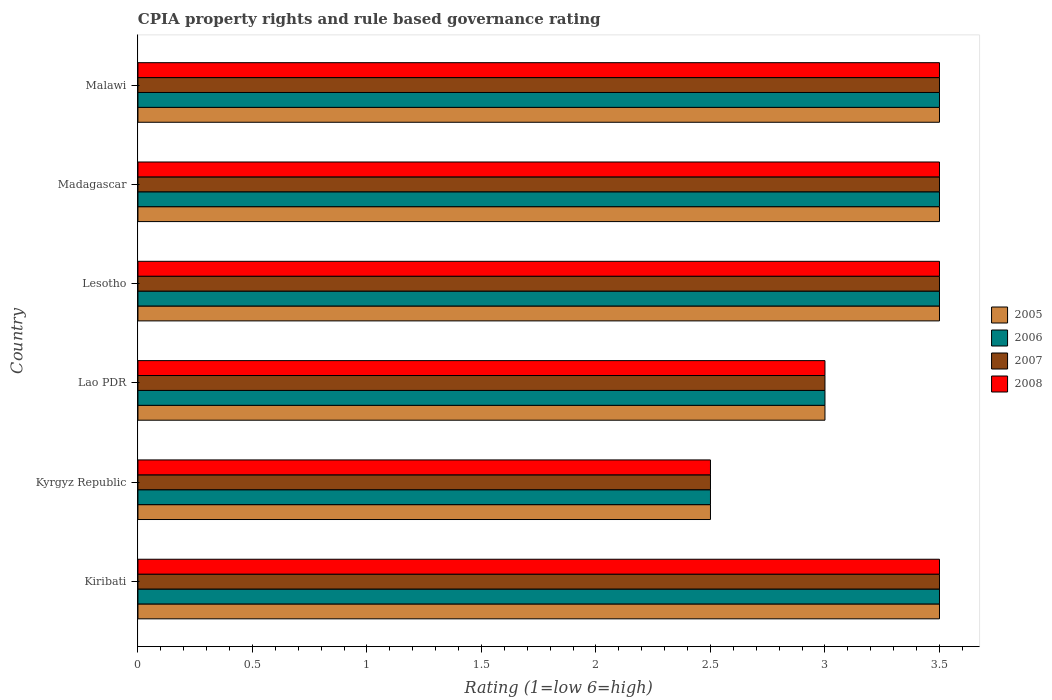How many different coloured bars are there?
Your answer should be compact. 4. How many groups of bars are there?
Keep it short and to the point. 6. How many bars are there on the 6th tick from the top?
Provide a short and direct response. 4. How many bars are there on the 4th tick from the bottom?
Offer a terse response. 4. What is the label of the 3rd group of bars from the top?
Offer a very short reply. Lesotho. In how many cases, is the number of bars for a given country not equal to the number of legend labels?
Your answer should be very brief. 0. In which country was the CPIA rating in 2008 maximum?
Provide a short and direct response. Kiribati. In which country was the CPIA rating in 2005 minimum?
Keep it short and to the point. Kyrgyz Republic. What is the average CPIA rating in 2007 per country?
Ensure brevity in your answer.  3.25. In how many countries, is the CPIA rating in 2006 greater than 0.2 ?
Provide a succinct answer. 6. What is the ratio of the CPIA rating in 2005 in Lesotho to that in Madagascar?
Offer a very short reply. 1. Is the difference between the CPIA rating in 2006 in Madagascar and Malawi greater than the difference between the CPIA rating in 2005 in Madagascar and Malawi?
Make the answer very short. No. What is the difference between the highest and the second highest CPIA rating in 2006?
Make the answer very short. 0. What is the difference between the highest and the lowest CPIA rating in 2005?
Your response must be concise. 1. In how many countries, is the CPIA rating in 2007 greater than the average CPIA rating in 2007 taken over all countries?
Offer a very short reply. 4. Is it the case that in every country, the sum of the CPIA rating in 2005 and CPIA rating in 2007 is greater than the sum of CPIA rating in 2008 and CPIA rating in 2006?
Keep it short and to the point. No. What does the 2nd bar from the top in Malawi represents?
Offer a terse response. 2007. Is it the case that in every country, the sum of the CPIA rating in 2007 and CPIA rating in 2008 is greater than the CPIA rating in 2005?
Your response must be concise. Yes. How many bars are there?
Offer a terse response. 24. Are all the bars in the graph horizontal?
Make the answer very short. Yes. How many countries are there in the graph?
Make the answer very short. 6. What is the difference between two consecutive major ticks on the X-axis?
Your response must be concise. 0.5. Does the graph contain any zero values?
Offer a very short reply. No. How many legend labels are there?
Provide a succinct answer. 4. What is the title of the graph?
Keep it short and to the point. CPIA property rights and rule based governance rating. What is the label or title of the X-axis?
Provide a succinct answer. Rating (1=low 6=high). What is the label or title of the Y-axis?
Keep it short and to the point. Country. What is the Rating (1=low 6=high) in 2006 in Kiribati?
Make the answer very short. 3.5. What is the Rating (1=low 6=high) of 2007 in Kiribati?
Provide a succinct answer. 3.5. What is the Rating (1=low 6=high) of 2005 in Kyrgyz Republic?
Provide a short and direct response. 2.5. What is the Rating (1=low 6=high) of 2007 in Kyrgyz Republic?
Your answer should be compact. 2.5. What is the Rating (1=low 6=high) in 2007 in Lesotho?
Your answer should be compact. 3.5. What is the Rating (1=low 6=high) in 2008 in Lesotho?
Ensure brevity in your answer.  3.5. What is the Rating (1=low 6=high) of 2005 in Malawi?
Provide a succinct answer. 3.5. What is the Rating (1=low 6=high) in 2007 in Malawi?
Keep it short and to the point. 3.5. Across all countries, what is the maximum Rating (1=low 6=high) of 2005?
Make the answer very short. 3.5. Across all countries, what is the maximum Rating (1=low 6=high) in 2006?
Provide a short and direct response. 3.5. Across all countries, what is the maximum Rating (1=low 6=high) of 2008?
Offer a very short reply. 3.5. Across all countries, what is the minimum Rating (1=low 6=high) of 2007?
Your answer should be very brief. 2.5. Across all countries, what is the minimum Rating (1=low 6=high) in 2008?
Your answer should be compact. 2.5. What is the total Rating (1=low 6=high) in 2005 in the graph?
Offer a very short reply. 19.5. What is the total Rating (1=low 6=high) in 2007 in the graph?
Make the answer very short. 19.5. What is the total Rating (1=low 6=high) in 2008 in the graph?
Your answer should be compact. 19.5. What is the difference between the Rating (1=low 6=high) in 2005 in Kiribati and that in Kyrgyz Republic?
Your response must be concise. 1. What is the difference between the Rating (1=low 6=high) of 2008 in Kiribati and that in Kyrgyz Republic?
Give a very brief answer. 1. What is the difference between the Rating (1=low 6=high) in 2005 in Kiribati and that in Lao PDR?
Provide a short and direct response. 0.5. What is the difference between the Rating (1=low 6=high) in 2006 in Kiribati and that in Lao PDR?
Ensure brevity in your answer.  0.5. What is the difference between the Rating (1=low 6=high) in 2007 in Kiribati and that in Lao PDR?
Keep it short and to the point. 0.5. What is the difference between the Rating (1=low 6=high) in 2007 in Kiribati and that in Lesotho?
Provide a succinct answer. 0. What is the difference between the Rating (1=low 6=high) in 2007 in Kiribati and that in Madagascar?
Your answer should be very brief. 0. What is the difference between the Rating (1=low 6=high) of 2005 in Kiribati and that in Malawi?
Provide a short and direct response. 0. What is the difference between the Rating (1=low 6=high) of 2007 in Kiribati and that in Malawi?
Your answer should be compact. 0. What is the difference between the Rating (1=low 6=high) in 2005 in Kyrgyz Republic and that in Lao PDR?
Keep it short and to the point. -0.5. What is the difference between the Rating (1=low 6=high) in 2007 in Kyrgyz Republic and that in Lao PDR?
Ensure brevity in your answer.  -0.5. What is the difference between the Rating (1=low 6=high) in 2005 in Kyrgyz Republic and that in Lesotho?
Give a very brief answer. -1. What is the difference between the Rating (1=low 6=high) of 2007 in Kyrgyz Republic and that in Lesotho?
Make the answer very short. -1. What is the difference between the Rating (1=low 6=high) of 2005 in Kyrgyz Republic and that in Madagascar?
Provide a succinct answer. -1. What is the difference between the Rating (1=low 6=high) of 2006 in Kyrgyz Republic and that in Madagascar?
Keep it short and to the point. -1. What is the difference between the Rating (1=low 6=high) of 2007 in Kyrgyz Republic and that in Madagascar?
Make the answer very short. -1. What is the difference between the Rating (1=low 6=high) of 2008 in Kyrgyz Republic and that in Madagascar?
Keep it short and to the point. -1. What is the difference between the Rating (1=low 6=high) in 2008 in Lao PDR and that in Lesotho?
Make the answer very short. -0.5. What is the difference between the Rating (1=low 6=high) of 2007 in Lao PDR and that in Madagascar?
Give a very brief answer. -0.5. What is the difference between the Rating (1=low 6=high) in 2008 in Lao PDR and that in Madagascar?
Offer a terse response. -0.5. What is the difference between the Rating (1=low 6=high) of 2006 in Lao PDR and that in Malawi?
Your answer should be very brief. -0.5. What is the difference between the Rating (1=low 6=high) in 2006 in Lesotho and that in Madagascar?
Your answer should be compact. 0. What is the difference between the Rating (1=low 6=high) in 2008 in Lesotho and that in Madagascar?
Give a very brief answer. 0. What is the difference between the Rating (1=low 6=high) in 2005 in Lesotho and that in Malawi?
Your response must be concise. 0. What is the difference between the Rating (1=low 6=high) of 2007 in Lesotho and that in Malawi?
Keep it short and to the point. 0. What is the difference between the Rating (1=low 6=high) in 2008 in Lesotho and that in Malawi?
Give a very brief answer. 0. What is the difference between the Rating (1=low 6=high) in 2005 in Madagascar and that in Malawi?
Give a very brief answer. 0. What is the difference between the Rating (1=low 6=high) in 2008 in Madagascar and that in Malawi?
Give a very brief answer. 0. What is the difference between the Rating (1=low 6=high) in 2005 in Kiribati and the Rating (1=low 6=high) in 2006 in Kyrgyz Republic?
Provide a succinct answer. 1. What is the difference between the Rating (1=low 6=high) in 2005 in Kiribati and the Rating (1=low 6=high) in 2007 in Kyrgyz Republic?
Provide a short and direct response. 1. What is the difference between the Rating (1=low 6=high) of 2005 in Kiribati and the Rating (1=low 6=high) of 2008 in Kyrgyz Republic?
Provide a short and direct response. 1. What is the difference between the Rating (1=low 6=high) of 2005 in Kiribati and the Rating (1=low 6=high) of 2007 in Lao PDR?
Make the answer very short. 0.5. What is the difference between the Rating (1=low 6=high) of 2006 in Kiribati and the Rating (1=low 6=high) of 2007 in Lao PDR?
Offer a terse response. 0.5. What is the difference between the Rating (1=low 6=high) of 2006 in Kiribati and the Rating (1=low 6=high) of 2008 in Lao PDR?
Provide a succinct answer. 0.5. What is the difference between the Rating (1=low 6=high) of 2007 in Kiribati and the Rating (1=low 6=high) of 2008 in Lao PDR?
Your response must be concise. 0.5. What is the difference between the Rating (1=low 6=high) of 2005 in Kiribati and the Rating (1=low 6=high) of 2006 in Lesotho?
Give a very brief answer. 0. What is the difference between the Rating (1=low 6=high) of 2007 in Kiribati and the Rating (1=low 6=high) of 2008 in Lesotho?
Ensure brevity in your answer.  0. What is the difference between the Rating (1=low 6=high) in 2005 in Kiribati and the Rating (1=low 6=high) in 2008 in Madagascar?
Your answer should be compact. 0. What is the difference between the Rating (1=low 6=high) of 2006 in Kiribati and the Rating (1=low 6=high) of 2007 in Madagascar?
Offer a terse response. 0. What is the difference between the Rating (1=low 6=high) of 2006 in Kiribati and the Rating (1=low 6=high) of 2008 in Madagascar?
Make the answer very short. 0. What is the difference between the Rating (1=low 6=high) in 2007 in Kiribati and the Rating (1=low 6=high) in 2008 in Madagascar?
Provide a succinct answer. 0. What is the difference between the Rating (1=low 6=high) in 2005 in Kiribati and the Rating (1=low 6=high) in 2006 in Malawi?
Offer a terse response. 0. What is the difference between the Rating (1=low 6=high) in 2005 in Kiribati and the Rating (1=low 6=high) in 2007 in Malawi?
Provide a succinct answer. 0. What is the difference between the Rating (1=low 6=high) in 2006 in Kiribati and the Rating (1=low 6=high) in 2008 in Malawi?
Offer a very short reply. 0. What is the difference between the Rating (1=low 6=high) in 2007 in Kiribati and the Rating (1=low 6=high) in 2008 in Malawi?
Provide a succinct answer. 0. What is the difference between the Rating (1=low 6=high) in 2005 in Kyrgyz Republic and the Rating (1=low 6=high) in 2006 in Lao PDR?
Make the answer very short. -0.5. What is the difference between the Rating (1=low 6=high) in 2005 in Kyrgyz Republic and the Rating (1=low 6=high) in 2007 in Lao PDR?
Offer a very short reply. -0.5. What is the difference between the Rating (1=low 6=high) of 2005 in Kyrgyz Republic and the Rating (1=low 6=high) of 2008 in Lao PDR?
Keep it short and to the point. -0.5. What is the difference between the Rating (1=low 6=high) of 2006 in Kyrgyz Republic and the Rating (1=low 6=high) of 2007 in Lao PDR?
Your response must be concise. -0.5. What is the difference between the Rating (1=low 6=high) in 2005 in Kyrgyz Republic and the Rating (1=low 6=high) in 2006 in Lesotho?
Offer a terse response. -1. What is the difference between the Rating (1=low 6=high) in 2007 in Kyrgyz Republic and the Rating (1=low 6=high) in 2008 in Lesotho?
Offer a very short reply. -1. What is the difference between the Rating (1=low 6=high) in 2005 in Kyrgyz Republic and the Rating (1=low 6=high) in 2007 in Madagascar?
Your answer should be very brief. -1. What is the difference between the Rating (1=low 6=high) in 2005 in Kyrgyz Republic and the Rating (1=low 6=high) in 2008 in Madagascar?
Offer a terse response. -1. What is the difference between the Rating (1=low 6=high) in 2006 in Kyrgyz Republic and the Rating (1=low 6=high) in 2007 in Madagascar?
Make the answer very short. -1. What is the difference between the Rating (1=low 6=high) in 2005 in Kyrgyz Republic and the Rating (1=low 6=high) in 2008 in Malawi?
Keep it short and to the point. -1. What is the difference between the Rating (1=low 6=high) in 2005 in Lao PDR and the Rating (1=low 6=high) in 2007 in Lesotho?
Offer a very short reply. -0.5. What is the difference between the Rating (1=low 6=high) of 2005 in Lao PDR and the Rating (1=low 6=high) of 2008 in Lesotho?
Ensure brevity in your answer.  -0.5. What is the difference between the Rating (1=low 6=high) in 2005 in Lao PDR and the Rating (1=low 6=high) in 2006 in Madagascar?
Provide a succinct answer. -0.5. What is the difference between the Rating (1=low 6=high) in 2005 in Lao PDR and the Rating (1=low 6=high) in 2007 in Madagascar?
Offer a terse response. -0.5. What is the difference between the Rating (1=low 6=high) in 2005 in Lao PDR and the Rating (1=low 6=high) in 2008 in Madagascar?
Provide a succinct answer. -0.5. What is the difference between the Rating (1=low 6=high) in 2006 in Lao PDR and the Rating (1=low 6=high) in 2007 in Madagascar?
Offer a terse response. -0.5. What is the difference between the Rating (1=low 6=high) of 2007 in Lao PDR and the Rating (1=low 6=high) of 2008 in Madagascar?
Offer a terse response. -0.5. What is the difference between the Rating (1=low 6=high) of 2005 in Lao PDR and the Rating (1=low 6=high) of 2006 in Malawi?
Ensure brevity in your answer.  -0.5. What is the difference between the Rating (1=low 6=high) of 2006 in Lao PDR and the Rating (1=low 6=high) of 2007 in Malawi?
Offer a very short reply. -0.5. What is the difference between the Rating (1=low 6=high) in 2006 in Lao PDR and the Rating (1=low 6=high) in 2008 in Malawi?
Keep it short and to the point. -0.5. What is the difference between the Rating (1=low 6=high) of 2006 in Lesotho and the Rating (1=low 6=high) of 2008 in Madagascar?
Your answer should be very brief. 0. What is the difference between the Rating (1=low 6=high) in 2007 in Lesotho and the Rating (1=low 6=high) in 2008 in Madagascar?
Provide a succinct answer. 0. What is the difference between the Rating (1=low 6=high) in 2005 in Lesotho and the Rating (1=low 6=high) in 2006 in Malawi?
Give a very brief answer. 0. What is the difference between the Rating (1=low 6=high) of 2006 in Lesotho and the Rating (1=low 6=high) of 2008 in Malawi?
Keep it short and to the point. 0. What is the difference between the Rating (1=low 6=high) in 2007 in Lesotho and the Rating (1=low 6=high) in 2008 in Malawi?
Your answer should be compact. 0. What is the difference between the Rating (1=low 6=high) of 2005 in Madagascar and the Rating (1=low 6=high) of 2006 in Malawi?
Provide a short and direct response. 0. What is the difference between the Rating (1=low 6=high) of 2005 in Madagascar and the Rating (1=low 6=high) of 2007 in Malawi?
Offer a terse response. 0. What is the difference between the Rating (1=low 6=high) of 2006 in Madagascar and the Rating (1=low 6=high) of 2007 in Malawi?
Offer a terse response. 0. What is the difference between the Rating (1=low 6=high) of 2006 in Madagascar and the Rating (1=low 6=high) of 2008 in Malawi?
Your answer should be compact. 0. What is the difference between the Rating (1=low 6=high) in 2007 in Madagascar and the Rating (1=low 6=high) in 2008 in Malawi?
Keep it short and to the point. 0. What is the average Rating (1=low 6=high) of 2005 per country?
Keep it short and to the point. 3.25. What is the average Rating (1=low 6=high) in 2007 per country?
Your response must be concise. 3.25. What is the difference between the Rating (1=low 6=high) in 2005 and Rating (1=low 6=high) in 2008 in Kiribati?
Keep it short and to the point. 0. What is the difference between the Rating (1=low 6=high) of 2006 and Rating (1=low 6=high) of 2008 in Kiribati?
Offer a very short reply. 0. What is the difference between the Rating (1=low 6=high) in 2005 and Rating (1=low 6=high) in 2006 in Kyrgyz Republic?
Keep it short and to the point. 0. What is the difference between the Rating (1=low 6=high) of 2006 and Rating (1=low 6=high) of 2008 in Kyrgyz Republic?
Your response must be concise. 0. What is the difference between the Rating (1=low 6=high) in 2007 and Rating (1=low 6=high) in 2008 in Kyrgyz Republic?
Ensure brevity in your answer.  0. What is the difference between the Rating (1=low 6=high) of 2005 and Rating (1=low 6=high) of 2006 in Lao PDR?
Your answer should be compact. 0. What is the difference between the Rating (1=low 6=high) of 2005 and Rating (1=low 6=high) of 2006 in Lesotho?
Make the answer very short. 0. What is the difference between the Rating (1=low 6=high) of 2005 and Rating (1=low 6=high) of 2007 in Lesotho?
Provide a succinct answer. 0. What is the difference between the Rating (1=low 6=high) of 2006 and Rating (1=low 6=high) of 2007 in Lesotho?
Ensure brevity in your answer.  0. What is the difference between the Rating (1=low 6=high) in 2006 and Rating (1=low 6=high) in 2008 in Lesotho?
Offer a terse response. 0. What is the difference between the Rating (1=low 6=high) in 2007 and Rating (1=low 6=high) in 2008 in Lesotho?
Your answer should be very brief. 0. What is the difference between the Rating (1=low 6=high) of 2006 and Rating (1=low 6=high) of 2008 in Madagascar?
Give a very brief answer. 0. What is the difference between the Rating (1=low 6=high) in 2007 and Rating (1=low 6=high) in 2008 in Madagascar?
Offer a very short reply. 0. What is the difference between the Rating (1=low 6=high) of 2005 and Rating (1=low 6=high) of 2007 in Malawi?
Give a very brief answer. 0. What is the difference between the Rating (1=low 6=high) in 2005 and Rating (1=low 6=high) in 2008 in Malawi?
Your answer should be compact. 0. What is the difference between the Rating (1=low 6=high) of 2006 and Rating (1=low 6=high) of 2007 in Malawi?
Your response must be concise. 0. What is the difference between the Rating (1=low 6=high) in 2006 and Rating (1=low 6=high) in 2008 in Malawi?
Make the answer very short. 0. What is the difference between the Rating (1=low 6=high) of 2007 and Rating (1=low 6=high) of 2008 in Malawi?
Your answer should be compact. 0. What is the ratio of the Rating (1=low 6=high) in 2006 in Kiribati to that in Kyrgyz Republic?
Your answer should be very brief. 1.4. What is the ratio of the Rating (1=low 6=high) of 2008 in Kiribati to that in Lao PDR?
Your answer should be compact. 1.17. What is the ratio of the Rating (1=low 6=high) in 2005 in Kiribati to that in Lesotho?
Keep it short and to the point. 1. What is the ratio of the Rating (1=low 6=high) of 2006 in Kiribati to that in Lesotho?
Provide a short and direct response. 1. What is the ratio of the Rating (1=low 6=high) in 2007 in Kiribati to that in Lesotho?
Offer a terse response. 1. What is the ratio of the Rating (1=low 6=high) in 2005 in Kiribati to that in Madagascar?
Your answer should be compact. 1. What is the ratio of the Rating (1=low 6=high) of 2007 in Kiribati to that in Madagascar?
Make the answer very short. 1. What is the ratio of the Rating (1=low 6=high) in 2008 in Kiribati to that in Madagascar?
Your answer should be very brief. 1. What is the ratio of the Rating (1=low 6=high) in 2005 in Kiribati to that in Malawi?
Provide a short and direct response. 1. What is the ratio of the Rating (1=low 6=high) in 2007 in Kiribati to that in Malawi?
Keep it short and to the point. 1. What is the ratio of the Rating (1=low 6=high) in 2008 in Kiribati to that in Malawi?
Offer a terse response. 1. What is the ratio of the Rating (1=low 6=high) in 2006 in Kyrgyz Republic to that in Lao PDR?
Ensure brevity in your answer.  0.83. What is the ratio of the Rating (1=low 6=high) of 2007 in Kyrgyz Republic to that in Lao PDR?
Give a very brief answer. 0.83. What is the ratio of the Rating (1=low 6=high) in 2008 in Kyrgyz Republic to that in Lesotho?
Your answer should be compact. 0.71. What is the ratio of the Rating (1=low 6=high) in 2008 in Kyrgyz Republic to that in Madagascar?
Provide a succinct answer. 0.71. What is the ratio of the Rating (1=low 6=high) of 2005 in Kyrgyz Republic to that in Malawi?
Your response must be concise. 0.71. What is the ratio of the Rating (1=low 6=high) in 2006 in Kyrgyz Republic to that in Malawi?
Provide a short and direct response. 0.71. What is the ratio of the Rating (1=low 6=high) of 2005 in Lao PDR to that in Lesotho?
Give a very brief answer. 0.86. What is the ratio of the Rating (1=low 6=high) of 2005 in Lao PDR to that in Madagascar?
Provide a short and direct response. 0.86. What is the ratio of the Rating (1=low 6=high) in 2007 in Lao PDR to that in Madagascar?
Ensure brevity in your answer.  0.86. What is the ratio of the Rating (1=low 6=high) of 2005 in Lao PDR to that in Malawi?
Ensure brevity in your answer.  0.86. What is the ratio of the Rating (1=low 6=high) of 2006 in Lao PDR to that in Malawi?
Ensure brevity in your answer.  0.86. What is the ratio of the Rating (1=low 6=high) of 2005 in Lesotho to that in Madagascar?
Your response must be concise. 1. What is the ratio of the Rating (1=low 6=high) of 2007 in Lesotho to that in Madagascar?
Offer a terse response. 1. What is the ratio of the Rating (1=low 6=high) in 2008 in Lesotho to that in Madagascar?
Make the answer very short. 1. What is the ratio of the Rating (1=low 6=high) of 2007 in Lesotho to that in Malawi?
Your answer should be very brief. 1. What is the ratio of the Rating (1=low 6=high) in 2006 in Madagascar to that in Malawi?
Your response must be concise. 1. What is the ratio of the Rating (1=low 6=high) in 2007 in Madagascar to that in Malawi?
Your answer should be compact. 1. What is the difference between the highest and the second highest Rating (1=low 6=high) in 2006?
Ensure brevity in your answer.  0. What is the difference between the highest and the second highest Rating (1=low 6=high) of 2007?
Provide a succinct answer. 0. What is the difference between the highest and the lowest Rating (1=low 6=high) in 2005?
Provide a succinct answer. 1. What is the difference between the highest and the lowest Rating (1=low 6=high) in 2007?
Keep it short and to the point. 1. 